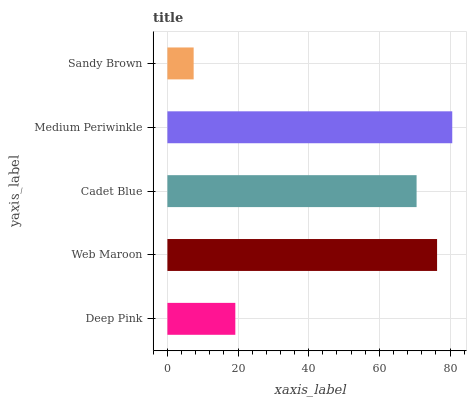Is Sandy Brown the minimum?
Answer yes or no. Yes. Is Medium Periwinkle the maximum?
Answer yes or no. Yes. Is Web Maroon the minimum?
Answer yes or no. No. Is Web Maroon the maximum?
Answer yes or no. No. Is Web Maroon greater than Deep Pink?
Answer yes or no. Yes. Is Deep Pink less than Web Maroon?
Answer yes or no. Yes. Is Deep Pink greater than Web Maroon?
Answer yes or no. No. Is Web Maroon less than Deep Pink?
Answer yes or no. No. Is Cadet Blue the high median?
Answer yes or no. Yes. Is Cadet Blue the low median?
Answer yes or no. Yes. Is Medium Periwinkle the high median?
Answer yes or no. No. Is Deep Pink the low median?
Answer yes or no. No. 